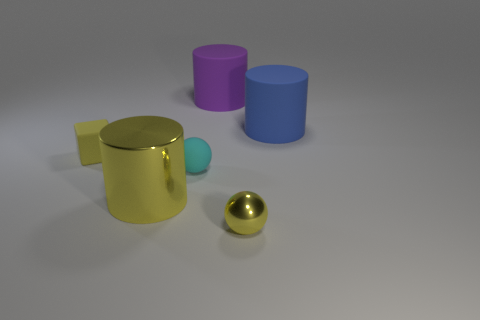Subtract 1 cylinders. How many cylinders are left? 2 Add 2 green metallic blocks. How many objects exist? 8 Subtract all blocks. How many objects are left? 5 Add 3 blue objects. How many blue objects exist? 4 Subtract 0 cyan cylinders. How many objects are left? 6 Subtract all balls. Subtract all things. How many objects are left? 2 Add 6 small yellow metal objects. How many small yellow metal objects are left? 7 